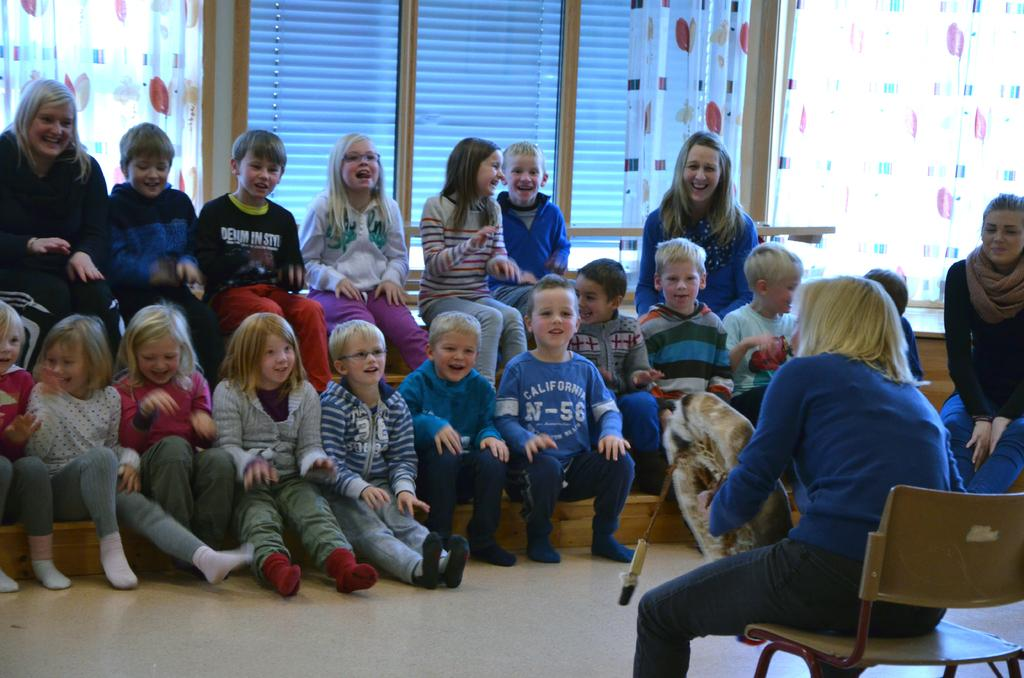How many people are in the image? There is a group of people in the image. What are the people doing in the image? The people are sitting on a bench. What can be seen in the background of the image? There is a curtain and a window in the background of the image. What type of wing is visible on the people in the image? There are no wings visible on the people in the image. Is there a fire burning in the background of the image? There is no fire present in the image. 